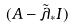<formula> <loc_0><loc_0><loc_500><loc_500>( A - \tilde { \lambda } _ { * } I )</formula> 